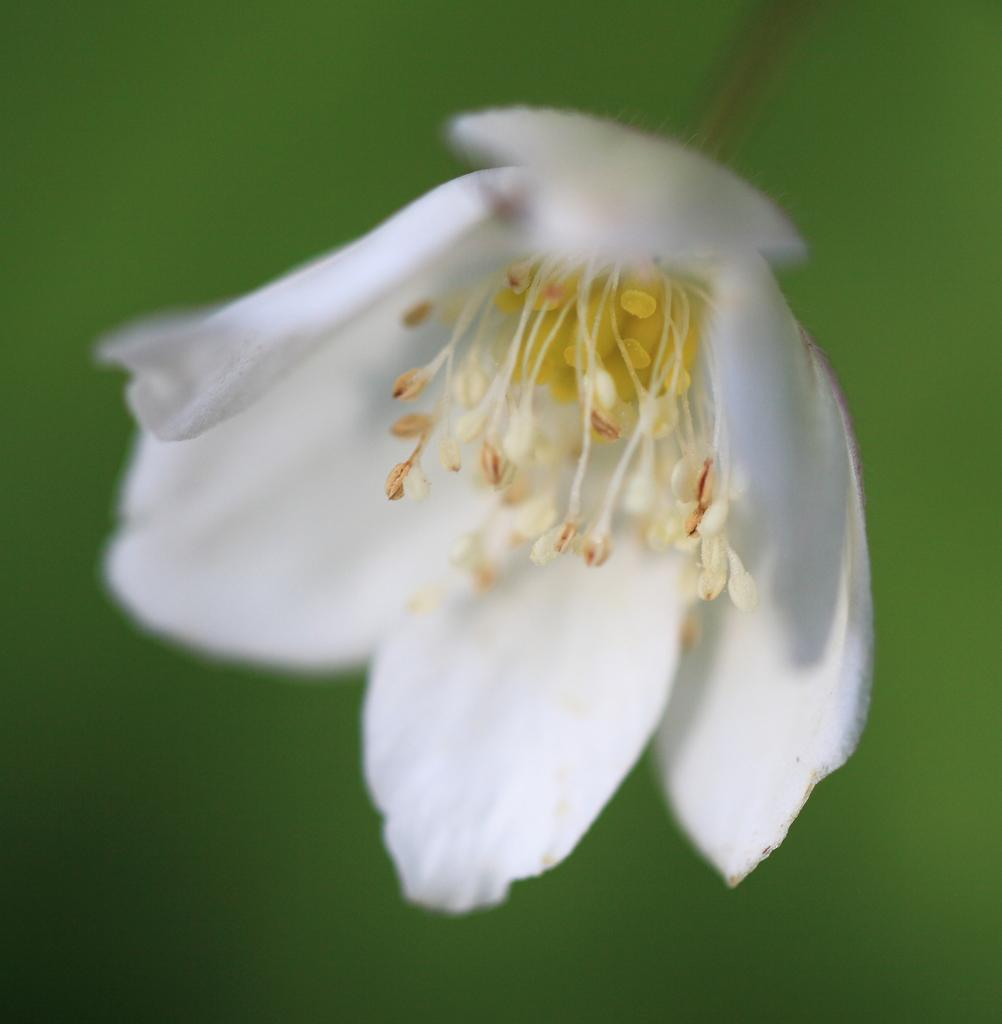What is the main subject of the image? There is a flower in the image. How many brothers does the flower have in the image? There are no people or siblings present in the image, as it features a flower. 